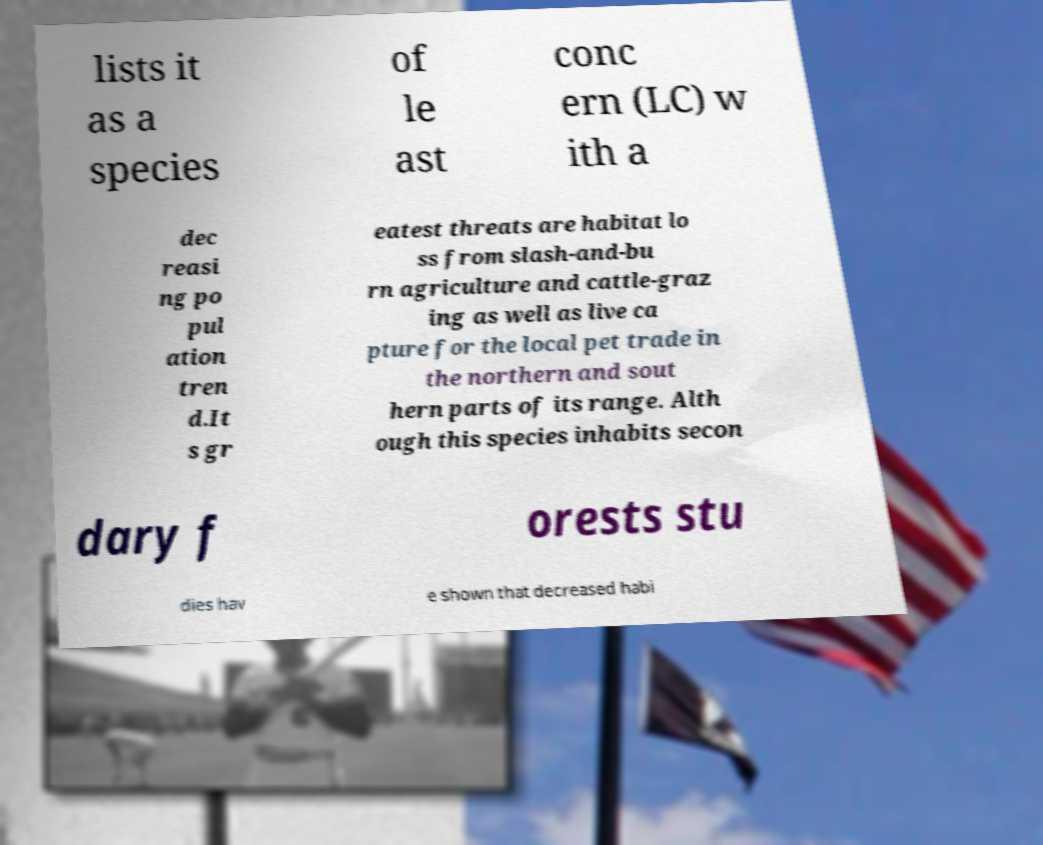I need the written content from this picture converted into text. Can you do that? lists it as a species of le ast conc ern (LC) w ith a dec reasi ng po pul ation tren d.It s gr eatest threats are habitat lo ss from slash-and-bu rn agriculture and cattle-graz ing as well as live ca pture for the local pet trade in the northern and sout hern parts of its range. Alth ough this species inhabits secon dary f orests stu dies hav e shown that decreased habi 